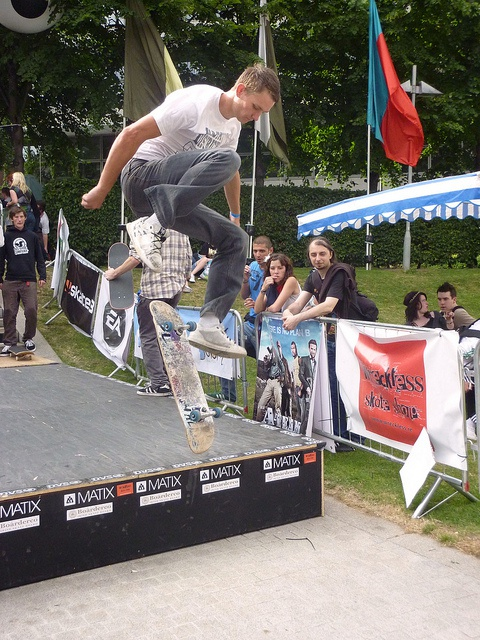Describe the objects in this image and their specific colors. I can see people in gray, lightgray, darkgray, and black tones, people in gray, black, tan, and lightgray tones, people in gray, black, and darkgray tones, skateboard in gray, darkgray, lightgray, and tan tones, and people in gray, darkgray, and lightgray tones in this image. 